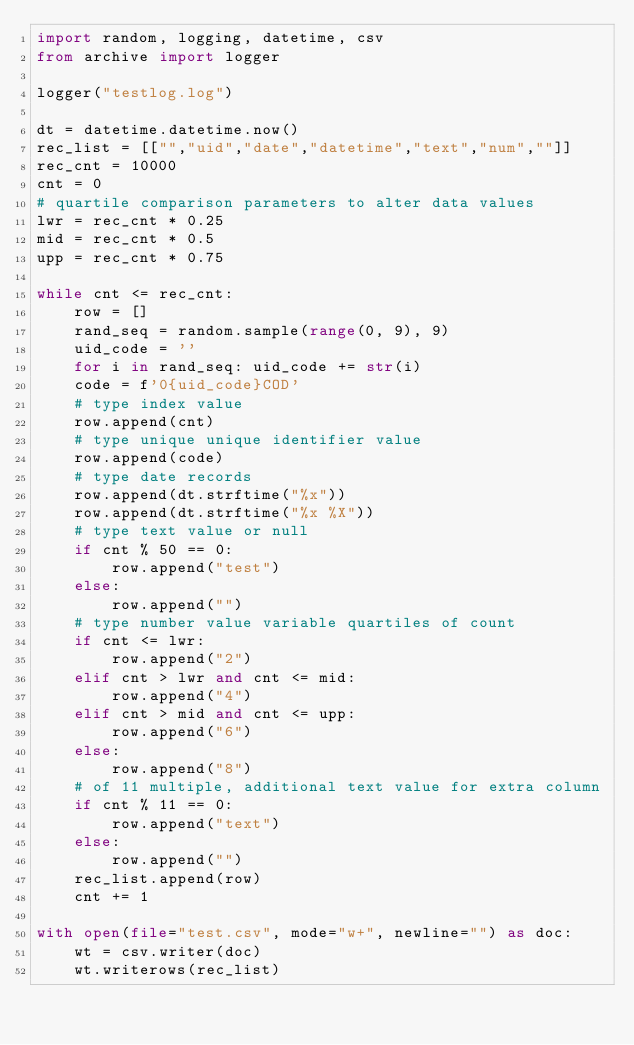<code> <loc_0><loc_0><loc_500><loc_500><_Python_>import random, logging, datetime, csv
from archive import logger

logger("testlog.log")

dt = datetime.datetime.now()
rec_list = [["","uid","date","datetime","text","num",""]]
rec_cnt = 10000
cnt = 0
# quartile comparison parameters to alter data values
lwr = rec_cnt * 0.25
mid = rec_cnt * 0.5
upp = rec_cnt * 0.75

while cnt <= rec_cnt:
    row = []
    rand_seq = random.sample(range(0, 9), 9)
    uid_code = ''
    for i in rand_seq: uid_code += str(i)
    code = f'0{uid_code}COD'
    # type index value
    row.append(cnt)
    # type unique unique identifier value
    row.append(code)
    # type date records
    row.append(dt.strftime("%x"))
    row.append(dt.strftime("%x %X"))
    # type text value or null
    if cnt % 50 == 0:
        row.append("test")
    else:
        row.append("")
    # type number value variable quartiles of count
    if cnt <= lwr:
        row.append("2")
    elif cnt > lwr and cnt <= mid:
        row.append("4")
    elif cnt > mid and cnt <= upp:
        row.append("6")
    else:
        row.append("8")
    # of 11 multiple, additional text value for extra column
    if cnt % 11 == 0:
        row.append("text")
    else:
        row.append("")
    rec_list.append(row)
    cnt += 1

with open(file="test.csv", mode="w+", newline="") as doc:
    wt = csv.writer(doc)
    wt.writerows(rec_list)</code> 